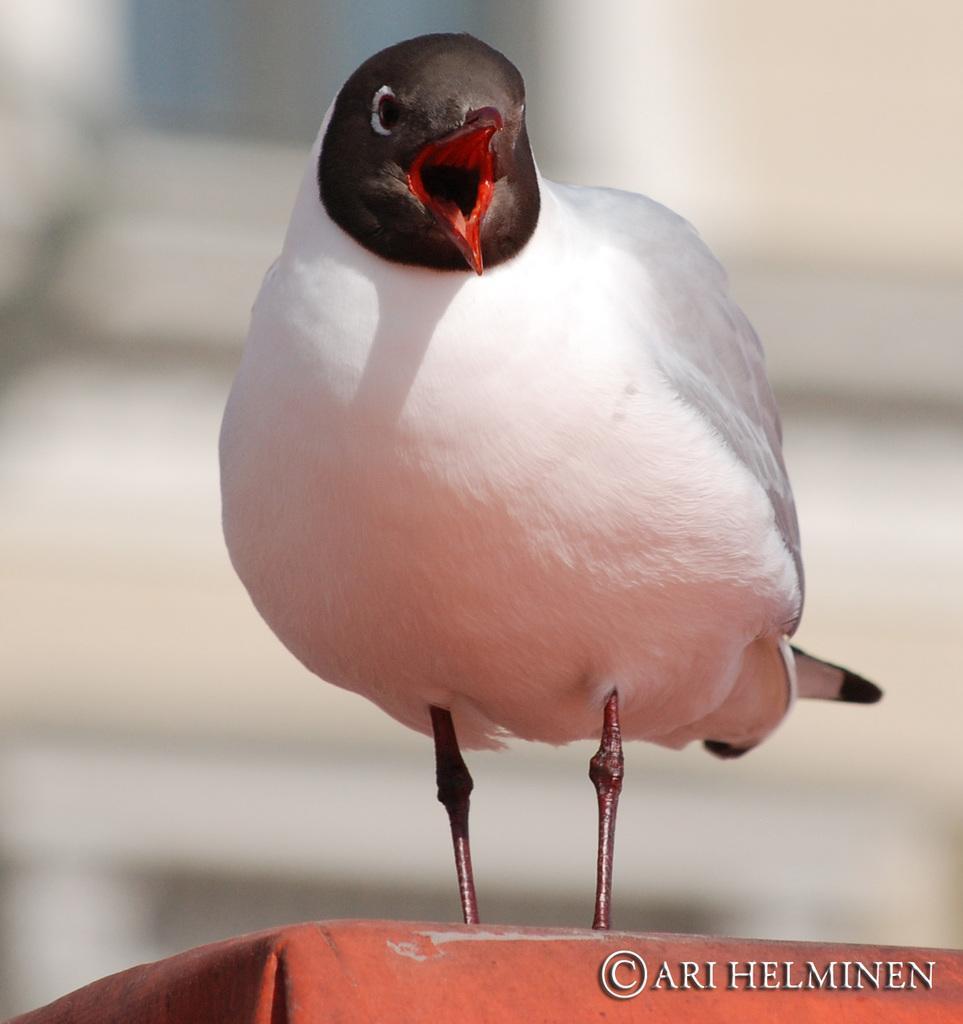Describe this image in one or two sentences. In this image I can see the bird and the bird is in white and brown color and the bird is on the orange color surface and I can see the blurred background. 